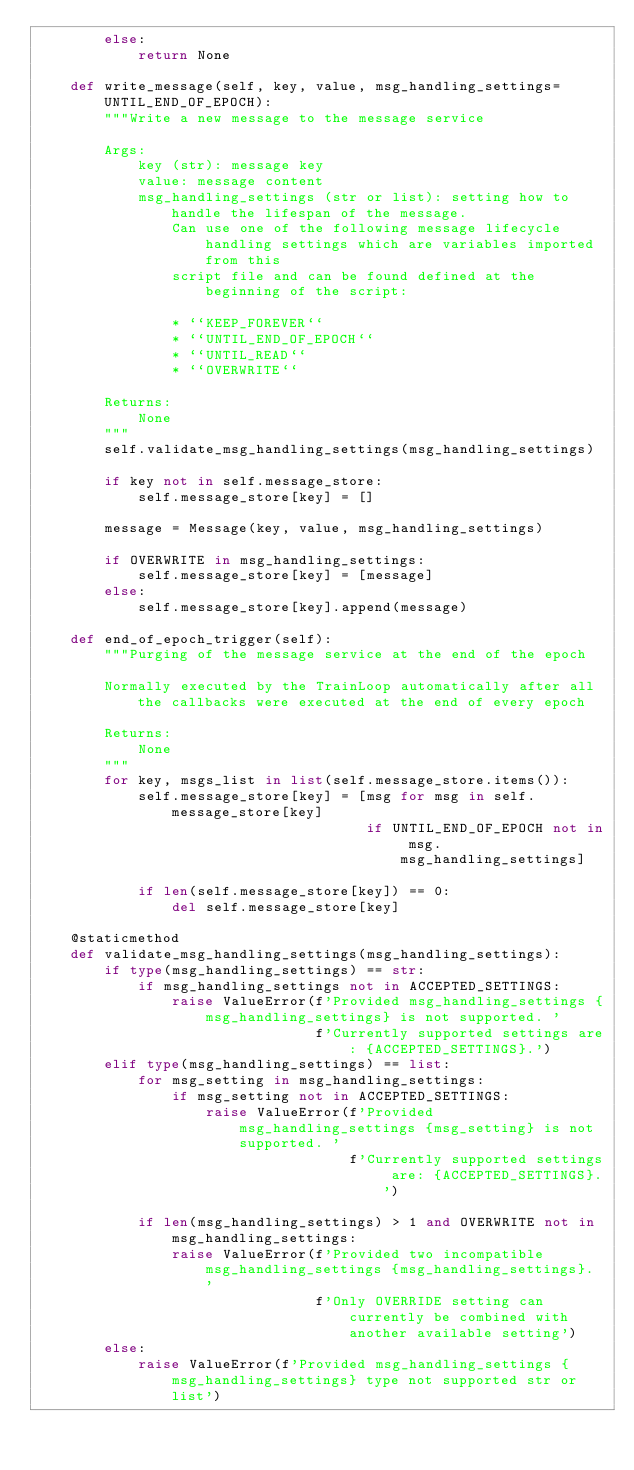Convert code to text. <code><loc_0><loc_0><loc_500><loc_500><_Python_>        else:
            return None

    def write_message(self, key, value, msg_handling_settings=UNTIL_END_OF_EPOCH):
        """Write a new message to the message service

        Args:
            key (str): message key
            value: message content
            msg_handling_settings (str or list): setting how to handle the lifespan of the message.
                Can use one of the following message lifecycle handling settings which are variables imported from this
                script file and can be found defined at the beginning of the script:

                * ``KEEP_FOREVER``
                * ``UNTIL_END_OF_EPOCH``
                * ``UNTIL_READ``
                * ``OVERWRITE``

        Returns:
            None
        """
        self.validate_msg_handling_settings(msg_handling_settings)

        if key not in self.message_store:
            self.message_store[key] = []

        message = Message(key, value, msg_handling_settings)

        if OVERWRITE in msg_handling_settings:
            self.message_store[key] = [message]
        else:
            self.message_store[key].append(message)

    def end_of_epoch_trigger(self):
        """Purging of the message service at the end of the epoch

        Normally executed by the TrainLoop automatically after all the callbacks were executed at the end of every epoch

        Returns:
            None
        """
        for key, msgs_list in list(self.message_store.items()):
            self.message_store[key] = [msg for msg in self.message_store[key]
                                       if UNTIL_END_OF_EPOCH not in msg.msg_handling_settings]

            if len(self.message_store[key]) == 0:
                del self.message_store[key]

    @staticmethod
    def validate_msg_handling_settings(msg_handling_settings):
        if type(msg_handling_settings) == str:
            if msg_handling_settings not in ACCEPTED_SETTINGS:
                raise ValueError(f'Provided msg_handling_settings {msg_handling_settings} is not supported. '
                                 f'Currently supported settings are: {ACCEPTED_SETTINGS}.')
        elif type(msg_handling_settings) == list:
            for msg_setting in msg_handling_settings:
                if msg_setting not in ACCEPTED_SETTINGS:
                    raise ValueError(f'Provided msg_handling_settings {msg_setting} is not supported. '
                                     f'Currently supported settings are: {ACCEPTED_SETTINGS}.')

            if len(msg_handling_settings) > 1 and OVERWRITE not in msg_handling_settings:
                raise ValueError(f'Provided two incompatible msg_handling_settings {msg_handling_settings}. '
                                 f'Only OVERRIDE setting can currently be combined with another available setting')
        else:
            raise ValueError(f'Provided msg_handling_settings {msg_handling_settings} type not supported str or list')
</code> 